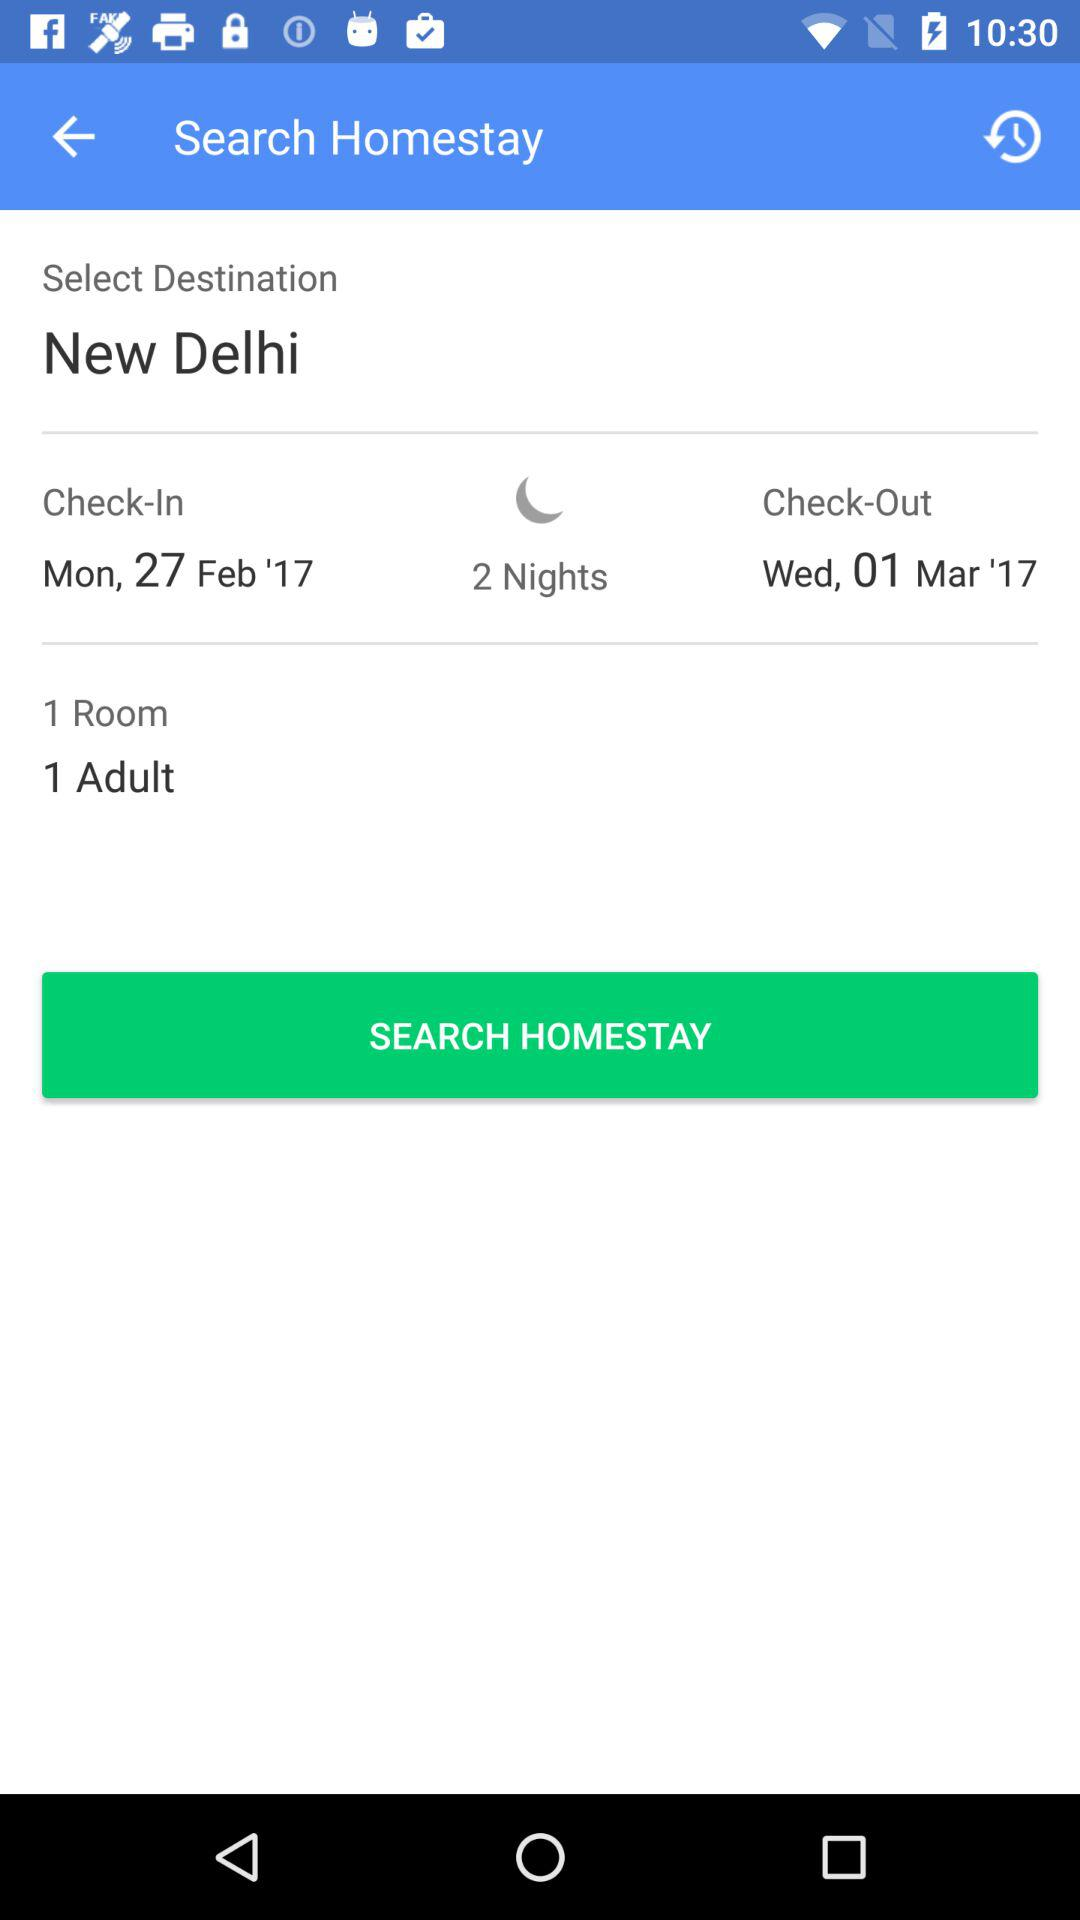How many days are in the stay?
Answer the question using a single word or phrase. 2 